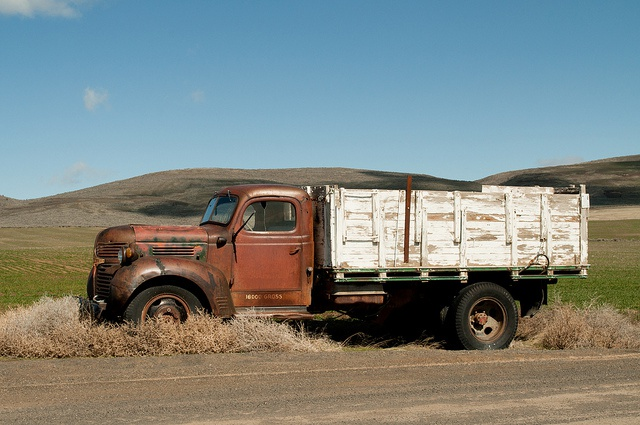Describe the objects in this image and their specific colors. I can see a truck in darkgray, black, ivory, brown, and maroon tones in this image. 